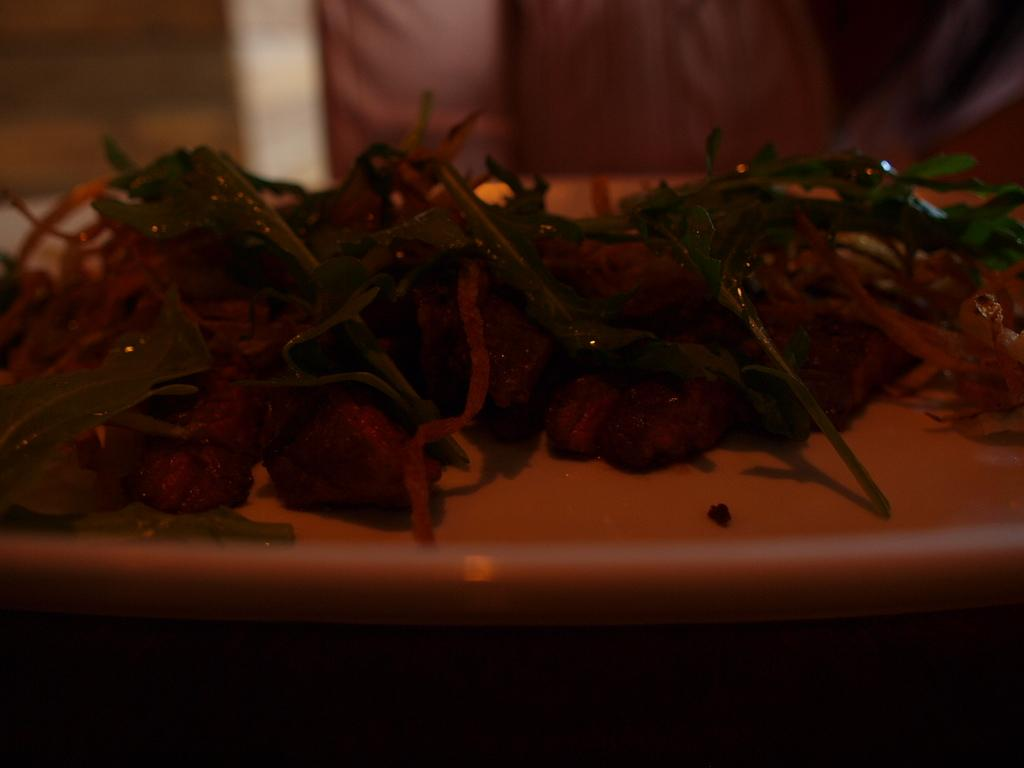What type of food can be seen in the image? The food in the image is in brown and green colors. Can you describe the color scheme of the food? The food is in brown and green colors. How would you describe the lighting in the image? The image is dark. How many houses are visible in the image? There are no houses visible in the image; it only features food. What type of transportation can be seen at the station in the image? There is no station or transportation present in the image; it only features food. 